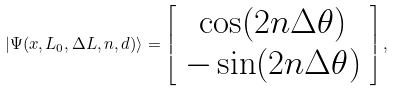Convert formula to latex. <formula><loc_0><loc_0><loc_500><loc_500>| \Psi ( { x } , L _ { 0 } , \Delta L , n , d ) \rangle = \left [ \begin{array} { c } \cos ( 2 n \Delta \theta ) \\ - \sin ( 2 n \Delta \theta ) \\ \end{array} \right ] ,</formula> 